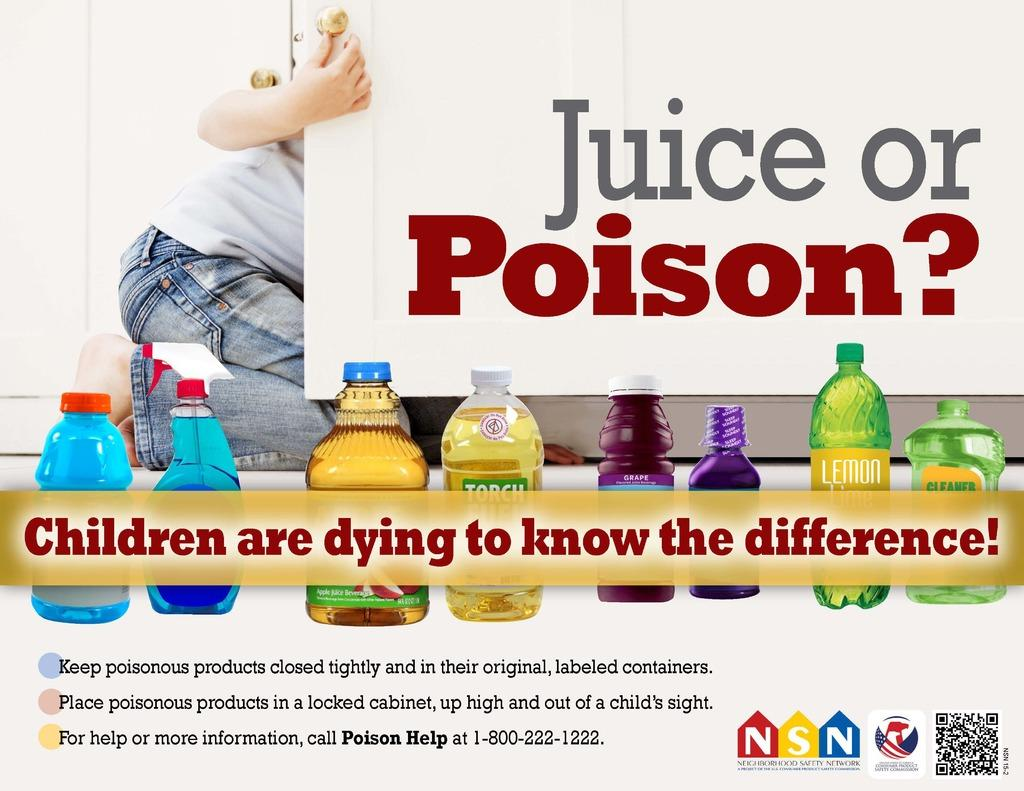<image>
Provide a brief description of the given image. a poster that asks about juice and poison 